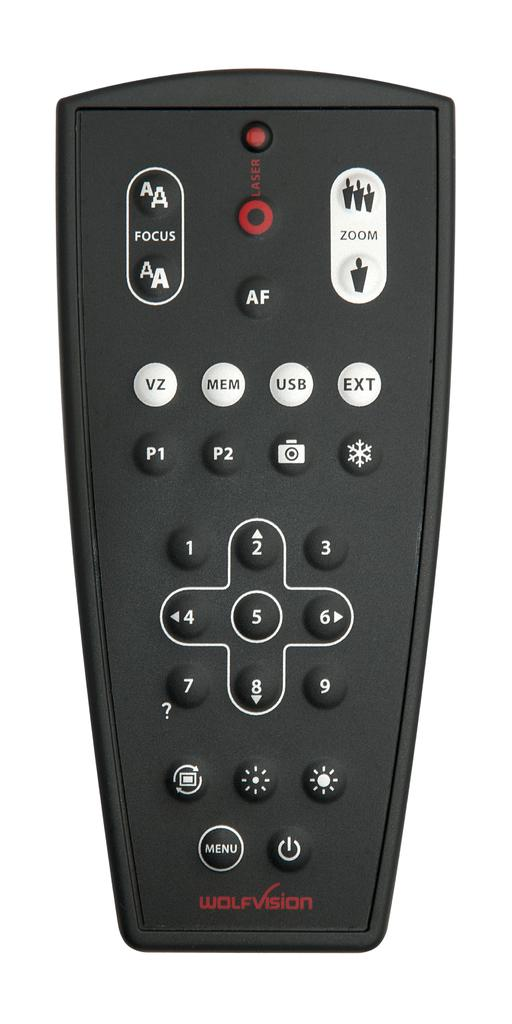<image>
Write a terse but informative summary of the picture. Remote control for a television with lots of button from the company Wolf Vision. 